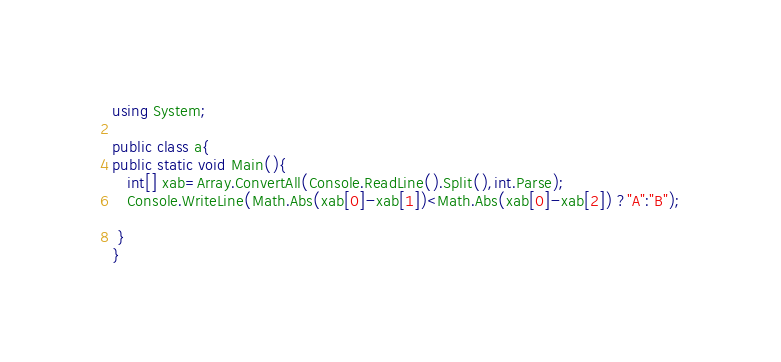Convert code to text. <code><loc_0><loc_0><loc_500><loc_500><_C#_>using System;

public class a{
public static void Main(){
   int[] xab=Array.ConvertAll(Console.ReadLine().Split(),int.Parse);
   Console.WriteLine(Math.Abs(xab[0]-xab[1])<Math.Abs(xab[0]-xab[2]) ?"A":"B");
                     
 }
}
</code> 